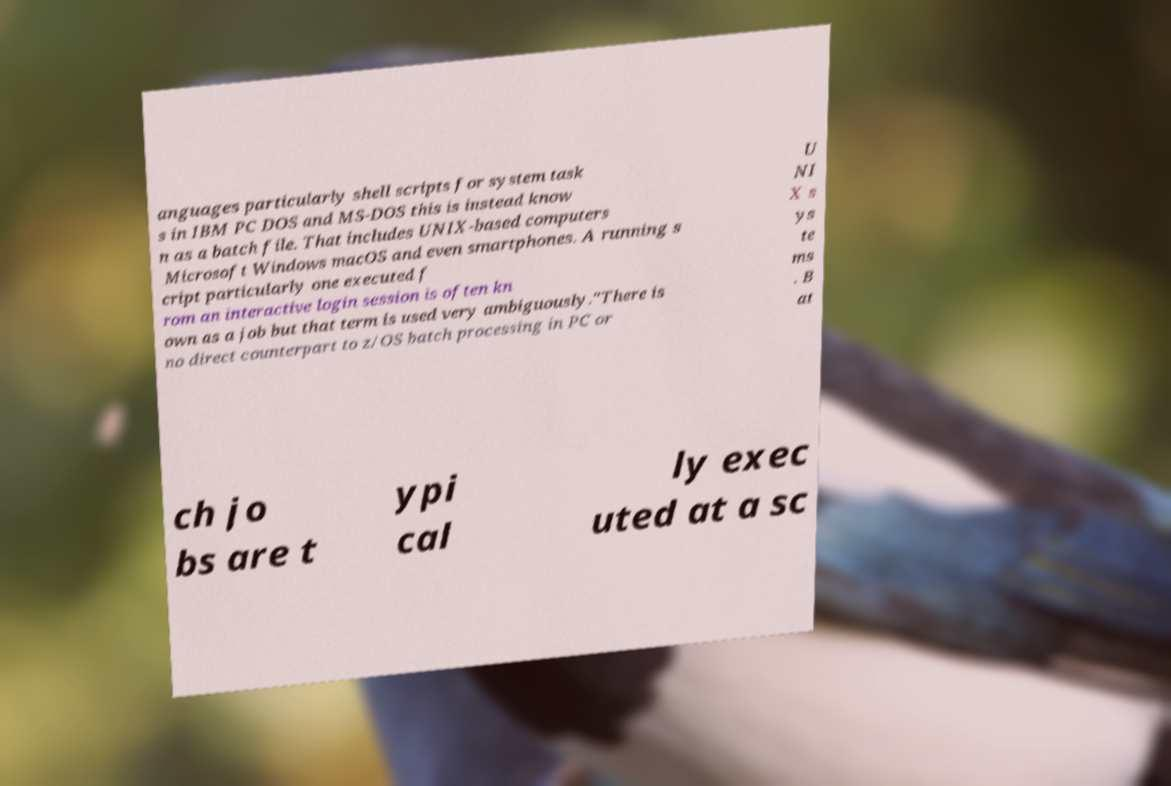Please identify and transcribe the text found in this image. anguages particularly shell scripts for system task s in IBM PC DOS and MS-DOS this is instead know n as a batch file. That includes UNIX-based computers Microsoft Windows macOS and even smartphones. A running s cript particularly one executed f rom an interactive login session is often kn own as a job but that term is used very ambiguously."There is no direct counterpart to z/OS batch processing in PC or U NI X s ys te ms . B at ch jo bs are t ypi cal ly exec uted at a sc 